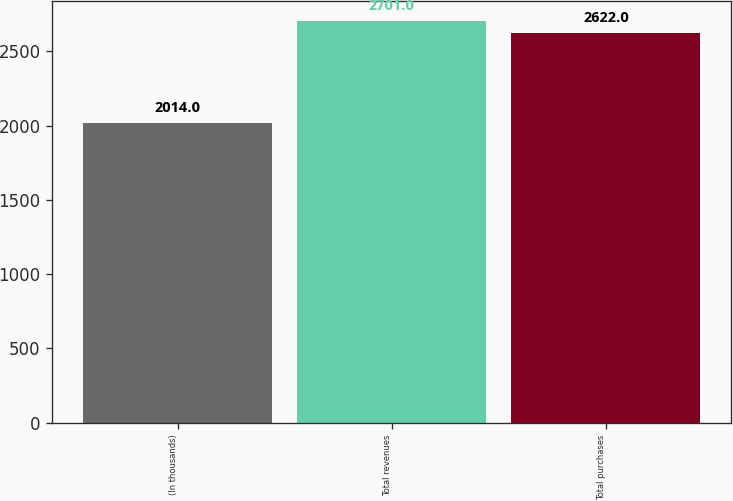Convert chart. <chart><loc_0><loc_0><loc_500><loc_500><bar_chart><fcel>(In thousands)<fcel>Total revenues<fcel>Total purchases<nl><fcel>2014<fcel>2701<fcel>2622<nl></chart> 